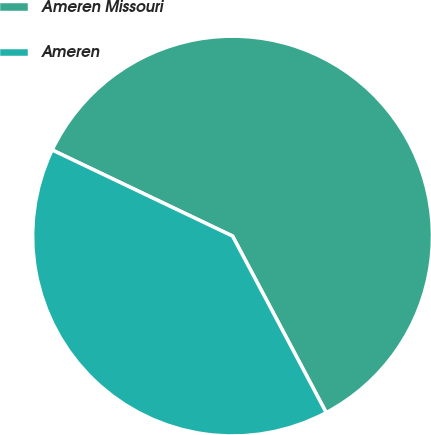<chart> <loc_0><loc_0><loc_500><loc_500><pie_chart><fcel>Ameren Missouri<fcel>Ameren<nl><fcel>60.15%<fcel>39.85%<nl></chart> 